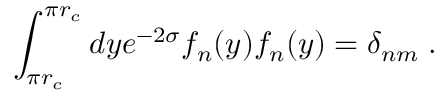<formula> <loc_0><loc_0><loc_500><loc_500>\int _ { \pi r _ { c } } ^ { \pi r _ { c } } d y e ^ { - 2 \sigma } f _ { n } ( y ) f _ { n } ( y ) = \delta _ { n m } \, .</formula> 